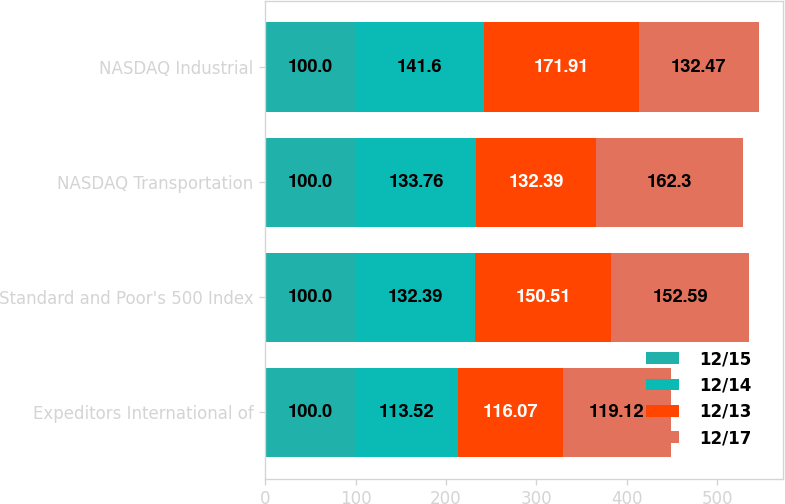<chart> <loc_0><loc_0><loc_500><loc_500><stacked_bar_chart><ecel><fcel>Expeditors International of<fcel>Standard and Poor's 500 Index<fcel>NASDAQ Transportation<fcel>NASDAQ Industrial<nl><fcel>12/15<fcel>100<fcel>100<fcel>100<fcel>100<nl><fcel>12/14<fcel>113.52<fcel>132.39<fcel>133.76<fcel>141.6<nl><fcel>12/13<fcel>116.07<fcel>150.51<fcel>132.39<fcel>171.91<nl><fcel>12/17<fcel>119.12<fcel>152.59<fcel>162.3<fcel>132.47<nl></chart> 